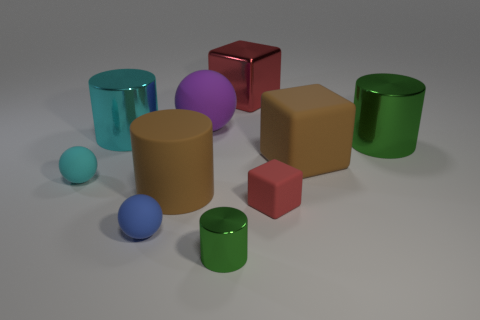There is a blue thing that is the same shape as the tiny cyan thing; what size is it?
Give a very brief answer. Small. There is another cylinder that is the same color as the small cylinder; what material is it?
Your answer should be compact. Metal. There is a matte thing that is the same color as the large metallic block; what size is it?
Your response must be concise. Small. There is a red shiny thing; is it the same size as the red cube that is in front of the purple thing?
Offer a terse response. No. Are any brown blocks visible?
Your answer should be compact. Yes. What size is the green metallic cylinder that is behind the small red matte cube?
Make the answer very short. Large. How many other cubes have the same color as the small matte cube?
Your response must be concise. 1. What number of cylinders are either yellow things or small cyan things?
Ensure brevity in your answer.  0. The tiny thing that is both behind the blue matte ball and on the right side of the cyan rubber object has what shape?
Ensure brevity in your answer.  Cube. Are there any blue cubes that have the same size as the cyan cylinder?
Offer a terse response. No. 